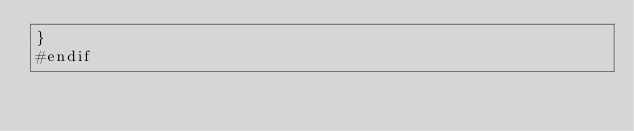Convert code to text. <code><loc_0><loc_0><loc_500><loc_500><_C_>}
#endif
</code> 